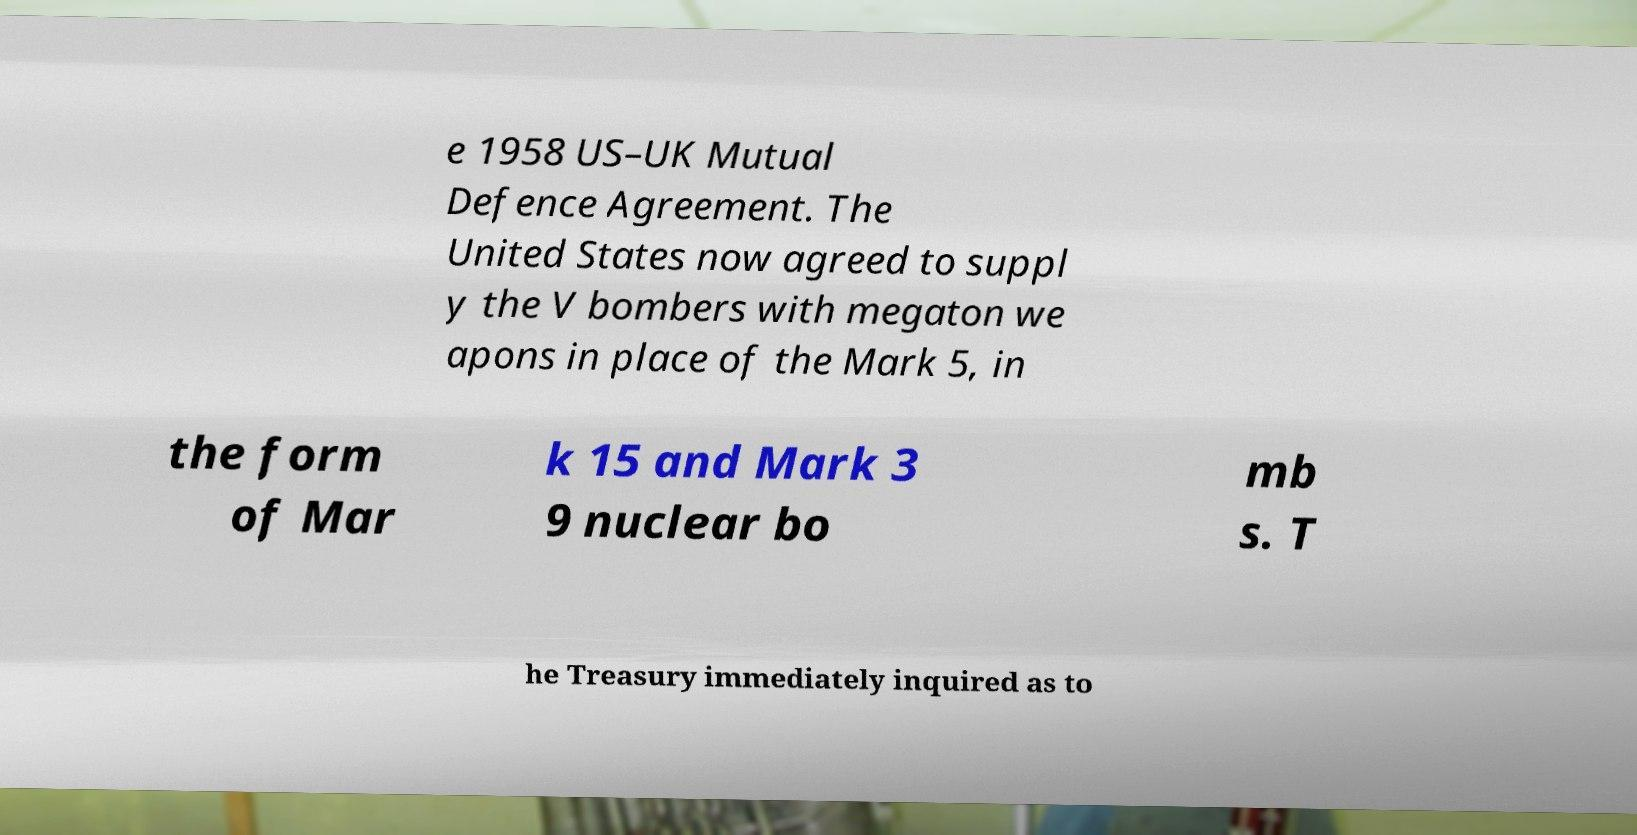Can you read and provide the text displayed in the image?This photo seems to have some interesting text. Can you extract and type it out for me? e 1958 US–UK Mutual Defence Agreement. The United States now agreed to suppl y the V bombers with megaton we apons in place of the Mark 5, in the form of Mar k 15 and Mark 3 9 nuclear bo mb s. T he Treasury immediately inquired as to 